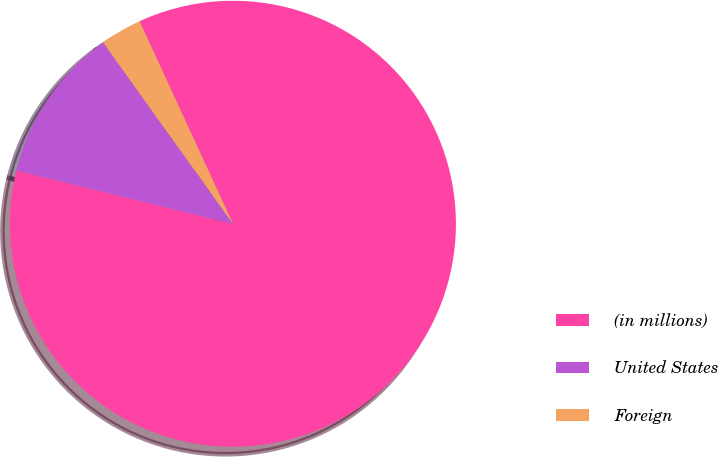<chart> <loc_0><loc_0><loc_500><loc_500><pie_chart><fcel>(in millions)<fcel>United States<fcel>Foreign<nl><fcel>85.71%<fcel>11.28%<fcel>3.01%<nl></chart> 